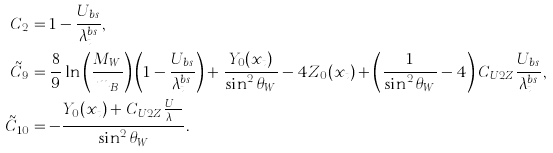<formula> <loc_0><loc_0><loc_500><loc_500>C _ { 2 } & = 1 - \frac { U _ { b s } } { \lambda _ { t } ^ { b s } } , \\ \tilde { C } _ { 9 } & = \frac { 8 } { 9 } \ln \left ( \frac { M _ { W } } { m _ { B } } \right ) \left ( 1 - \frac { U _ { b s } } { \lambda _ { t } ^ { b s } } \right ) + \frac { Y _ { 0 } ( x _ { t } ) } { \sin ^ { 2 } \theta _ { W } } - 4 Z _ { 0 } ( x _ { t } ) + \left ( \frac { 1 } { \sin ^ { 2 } \theta _ { W } } - 4 \right ) C _ { U 2 Z } \frac { U _ { b s } } { \lambda _ { t } ^ { b s } } , \\ \tilde { C } _ { 1 0 } & = - \frac { Y _ { 0 } ( x _ { t } ) + C _ { U 2 Z } \frac { U _ { b s } } { \lambda _ { t } ^ { b s } } } { \sin ^ { 2 } \theta _ { W } } .</formula> 